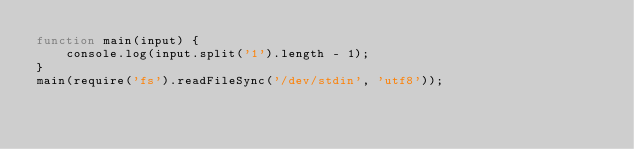<code> <loc_0><loc_0><loc_500><loc_500><_JavaScript_>function main(input) {
    console.log(input.split('1').length - 1);
}
main(require('fs').readFileSync('/dev/stdin', 'utf8'));</code> 